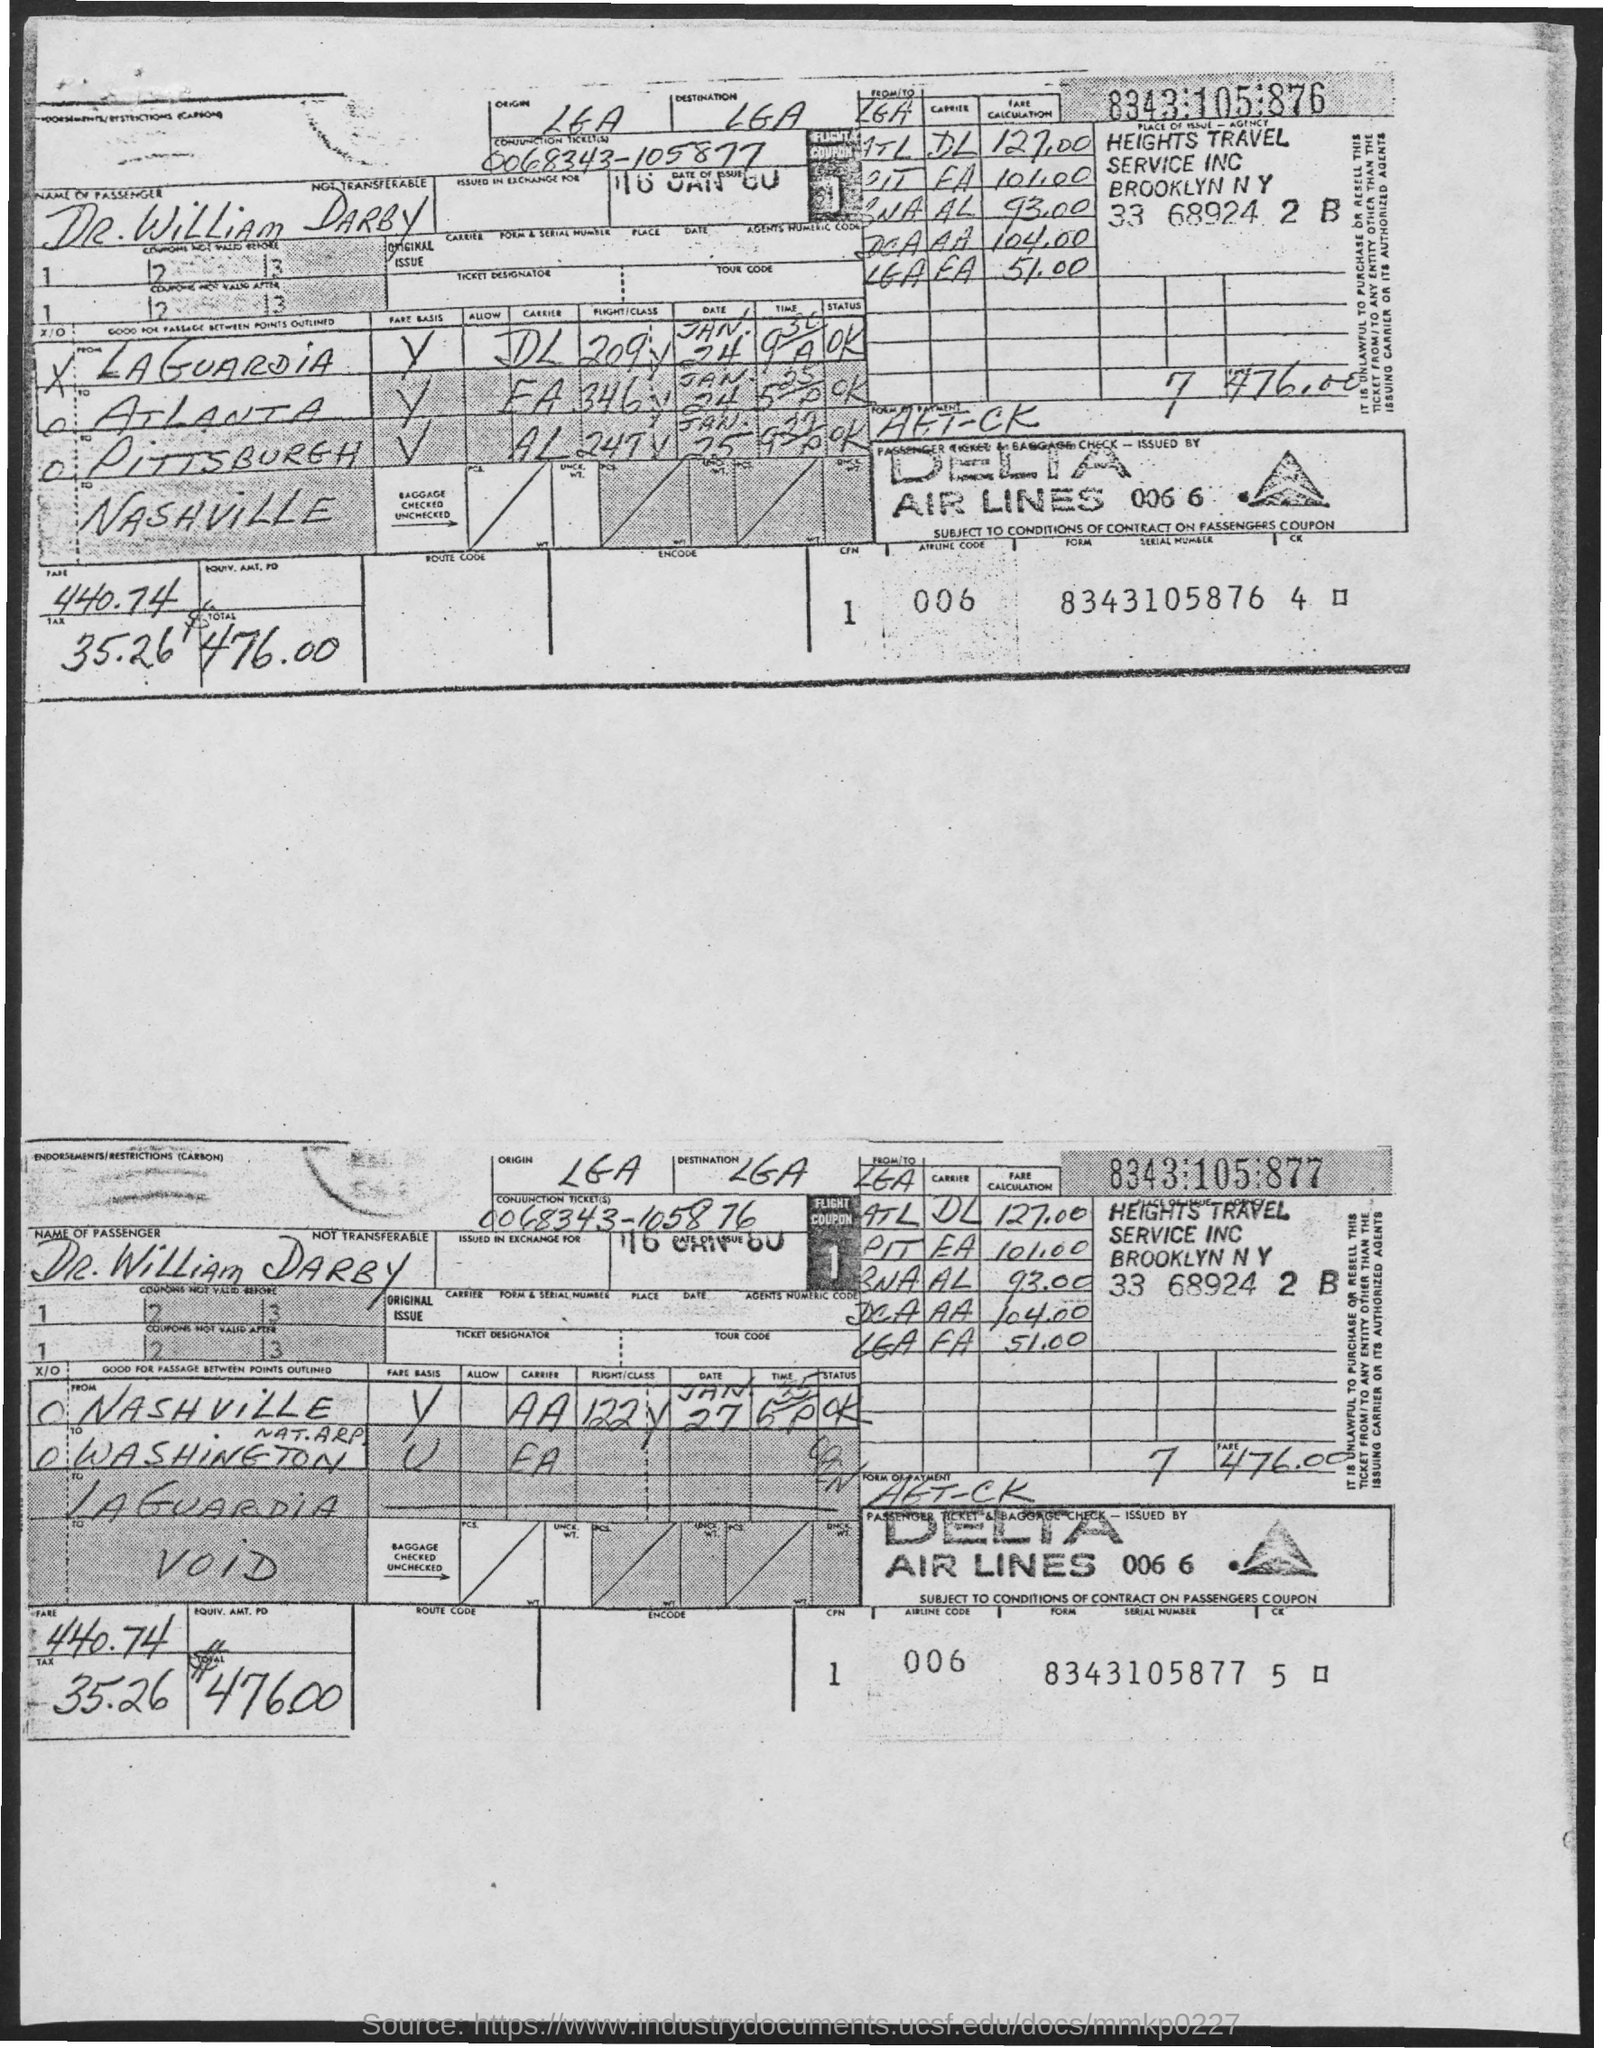What is the airline code?
Offer a very short reply. 006. What is the place of issue- agency?
Offer a terse response. HEIGHTS TRAVEL SERVICE INC BROOKLYN NY. What is the name of the passenger?
Provide a succinct answer. Dr. William Darby. What is the total amount?
Make the answer very short. $476.00. What is the form serial number?
Give a very brief answer. 8343105876 4. 